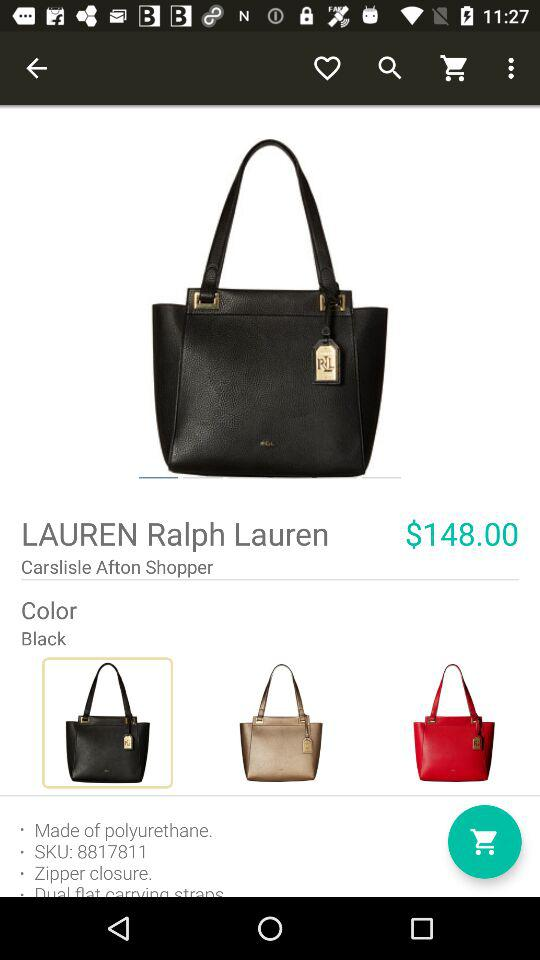How many colors are there for this item?
Answer the question using a single word or phrase. 3 